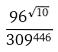Convert formula to latex. <formula><loc_0><loc_0><loc_500><loc_500>\frac { 9 6 ^ { \sqrt { 1 0 } } } { 3 0 9 ^ { 4 4 6 } }</formula> 